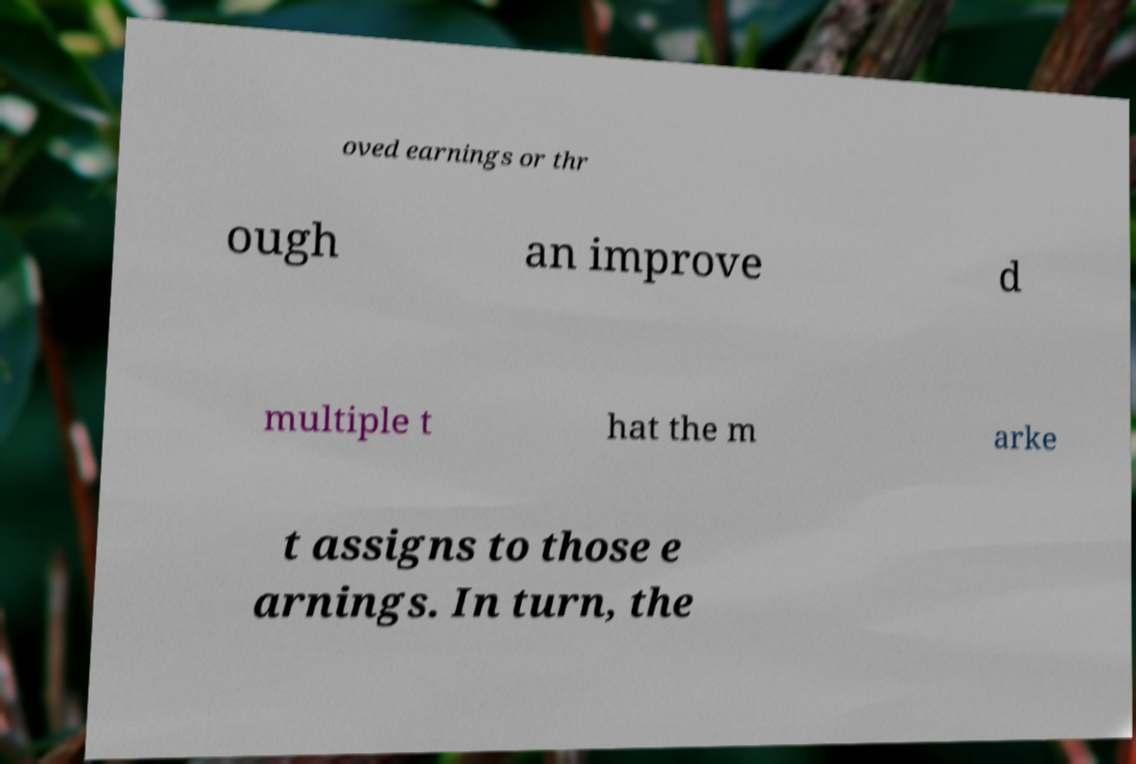Please read and relay the text visible in this image. What does it say? oved earnings or thr ough an improve d multiple t hat the m arke t assigns to those e arnings. In turn, the 